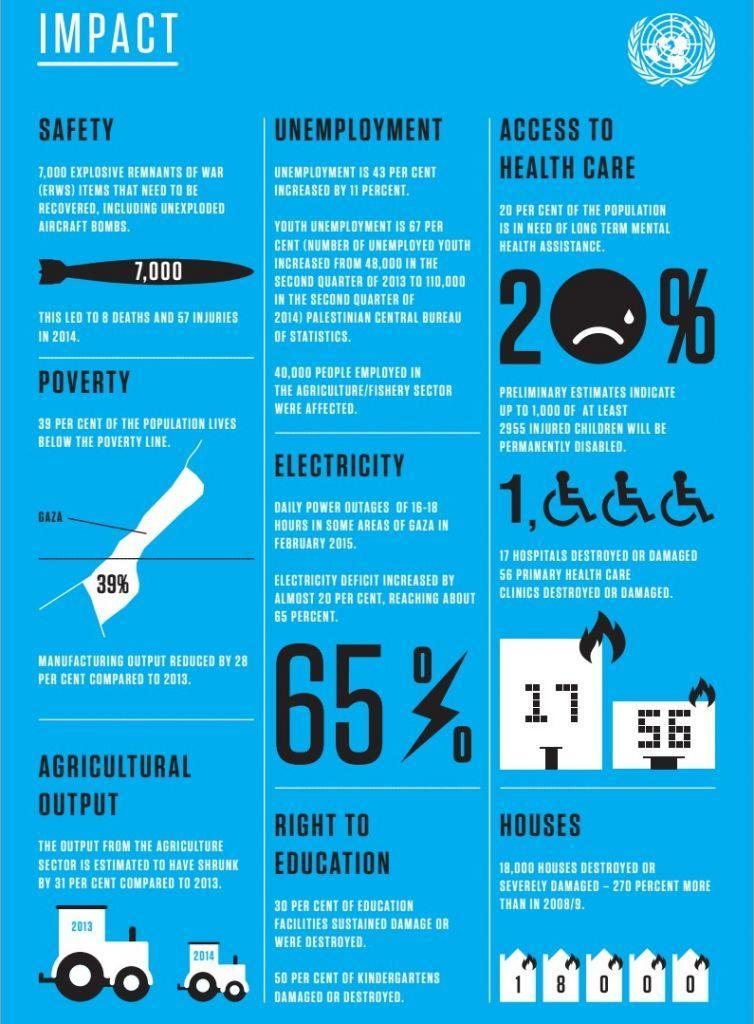What happened to hospitals and primary health care clinics?
Answer the question with a short phrase. destroyed or damaged By what percentage did unemployment increase? 11 percent How many people in the agriculture/fishing industry were affected? 40,000 What type of assistance is needed by 20% of the population? long term mental health assistance How many deaths were caused in 2014 due to explosive remnants of war? 8 By how much did agricultural output shrink compared to 2013? 31 per cent 